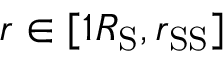<formula> <loc_0><loc_0><loc_500><loc_500>r \in [ 1 R _ { S } , r _ { S S } ]</formula> 